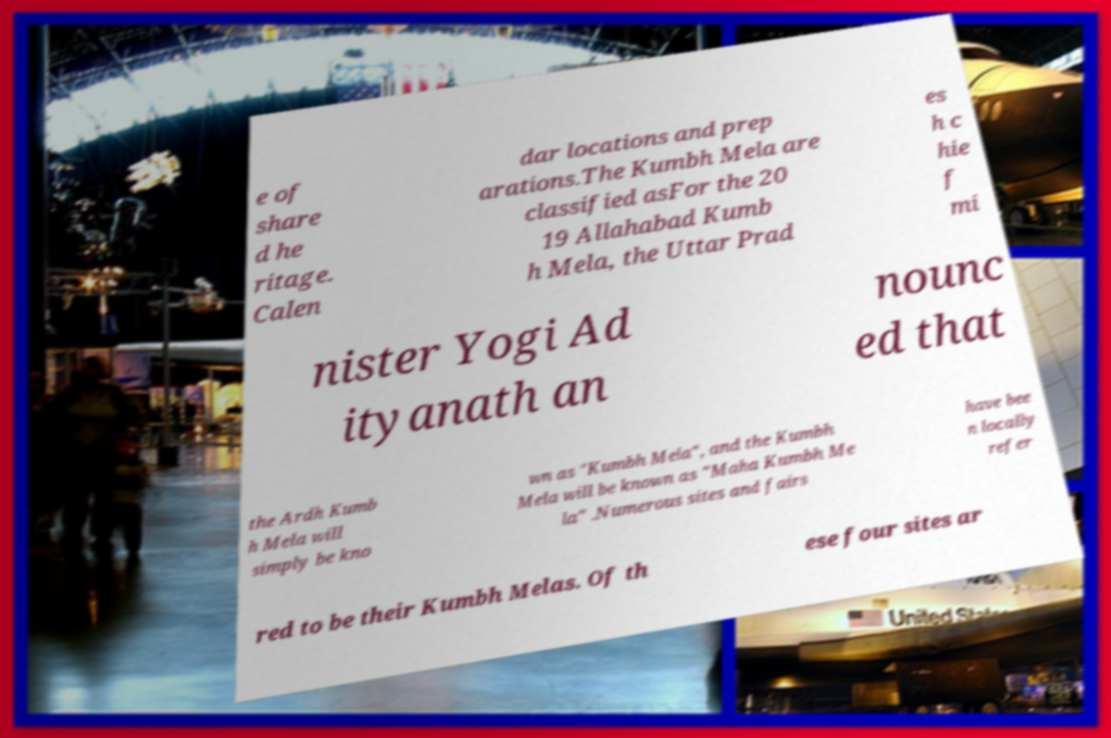I need the written content from this picture converted into text. Can you do that? e of share d he ritage. Calen dar locations and prep arations.The Kumbh Mela are classified asFor the 20 19 Allahabad Kumb h Mela, the Uttar Prad es h c hie f mi nister Yogi Ad ityanath an nounc ed that the Ardh Kumb h Mela will simply be kno wn as "Kumbh Mela", and the Kumbh Mela will be known as "Maha Kumbh Me la" .Numerous sites and fairs have bee n locally refer red to be their Kumbh Melas. Of th ese four sites ar 